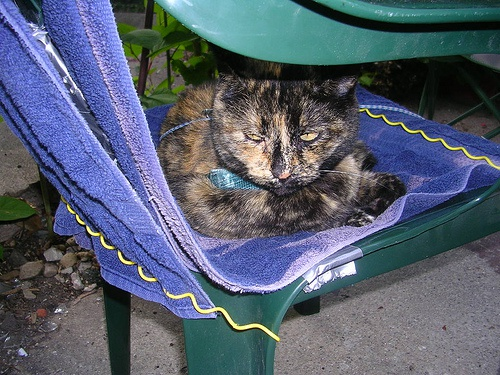Describe the objects in this image and their specific colors. I can see chair in blue, violet, teal, and black tones and cat in blue, black, gray, and darkgray tones in this image. 